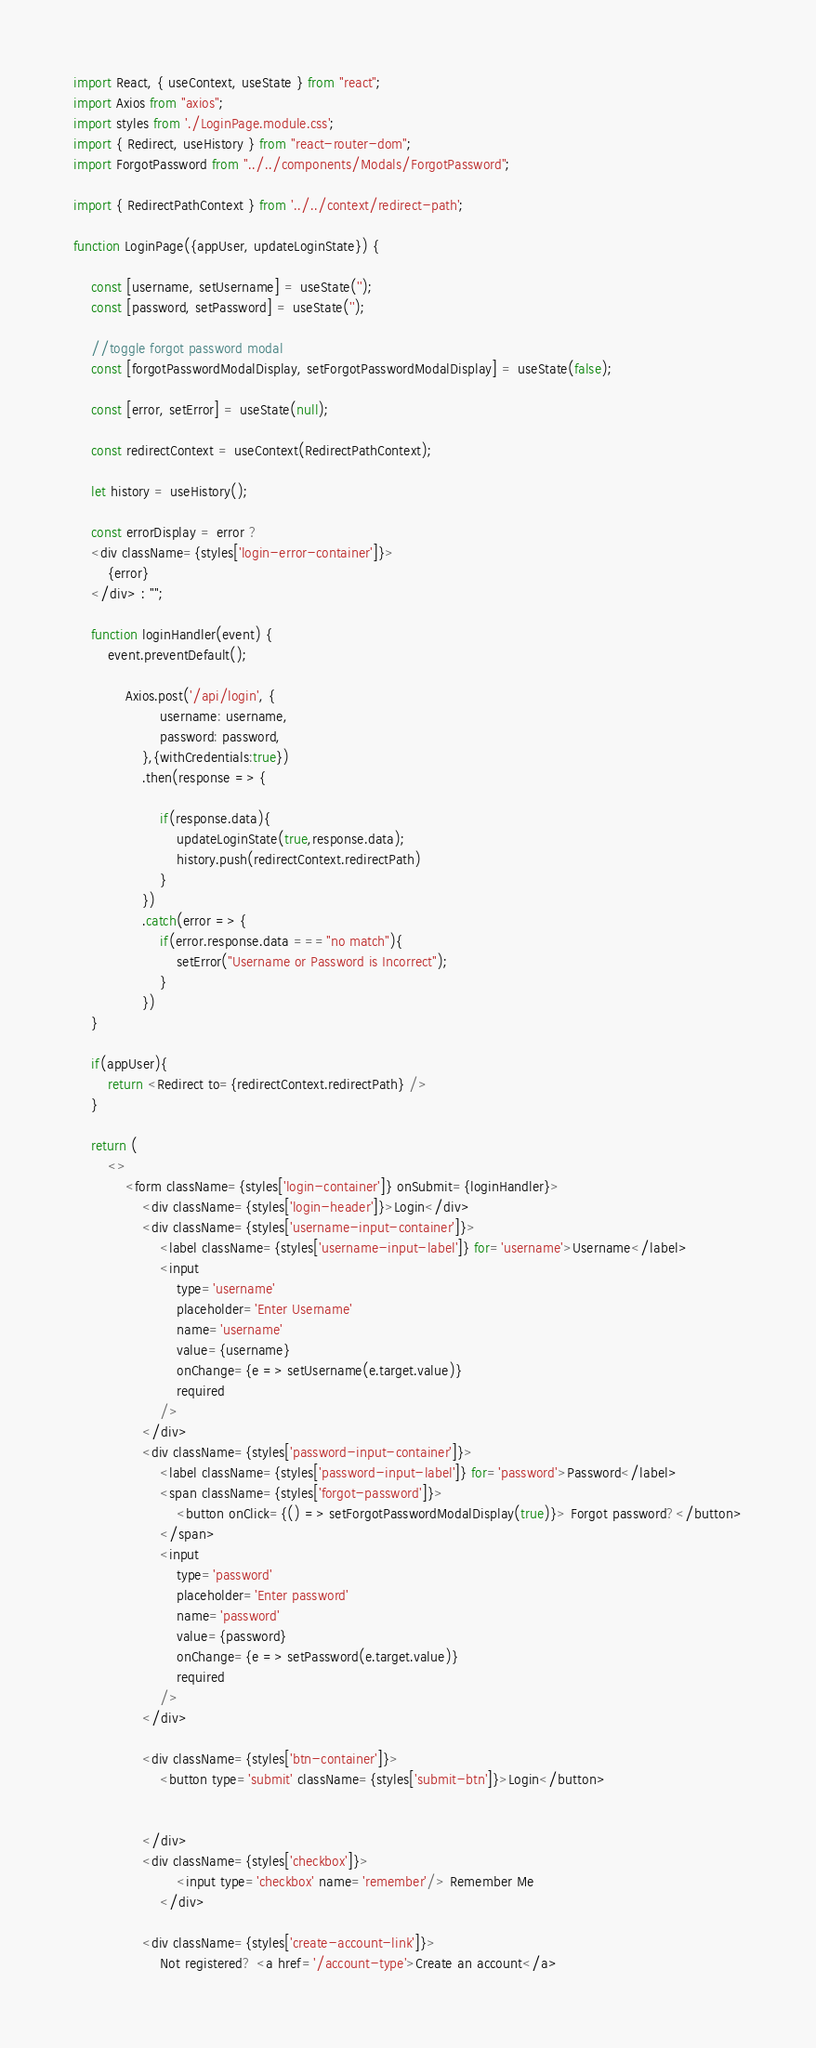Convert code to text. <code><loc_0><loc_0><loc_500><loc_500><_JavaScript_>import React, { useContext, useState } from "react";
import Axios from "axios";
import styles from './LoginPage.module.css';
import { Redirect, useHistory } from "react-router-dom";
import ForgotPassword from "../../components/Modals/ForgotPassword";

import { RedirectPathContext } from '../../context/redirect-path';

function LoginPage({appUser, updateLoginState}) {

    const [username, setUsername] = useState('');
    const [password, setPassword] = useState('');

    //toggle forgot password modal
    const [forgotPasswordModalDisplay, setForgotPasswordModalDisplay] = useState(false);

    const [error, setError] = useState(null);

    const redirectContext = useContext(RedirectPathContext);

    let history = useHistory();

    const errorDisplay = error ? 
    <div className={styles['login-error-container']}>
        {error}
    </div> : "";

    function loginHandler(event) {
        event.preventDefault();
            
            Axios.post('/api/login', {
                    username: username,
                    password: password,
                },{withCredentials:true})
                .then(response => {

                    if(response.data){
                        updateLoginState(true,response.data);
                        history.push(redirectContext.redirectPath)
                    }
                })
                .catch(error => {
                    if(error.response.data ==="no match"){
                        setError("Username or Password is Incorrect");
                    }
                })
    }

    if(appUser){
        return <Redirect to={redirectContext.redirectPath} />
    }

    return (
        <>
            <form className={styles['login-container']} onSubmit={loginHandler}>
                <div className={styles['login-header']}>Login</div>
                <div className={styles['username-input-container']}>
                    <label className={styles['username-input-label']} for='username'>Username</label>
                    <input
                        type='username'
                        placeholder='Enter Username'
                        name='username'
                        value={username}
                        onChange={e => setUsername(e.target.value)}
                        required
                    />
                </div>
                <div className={styles['password-input-container']}>
                    <label className={styles['password-input-label']} for='password'>Password</label>
                    <span className={styles['forgot-password']}>
                        <button onClick={() => setForgotPasswordModalDisplay(true)}> Forgot password?</button>
                    </span>
                    <input
                        type='password'
                        placeholder='Enter password'
                        name='password'
                        value={password}
                        onChange={e => setPassword(e.target.value)}
                        required
                    />
                </div>

                <div className={styles['btn-container']}>
                    <button type='submit' className={styles['submit-btn']}>Login</button>


                </div>
                <div className={styles['checkbox']}>
                        <input type='checkbox' name='remember'/> Remember Me
                    </div>

                <div className={styles['create-account-link']}>
                    Not registered? <a href='/account-type'>Create an account</a></code> 